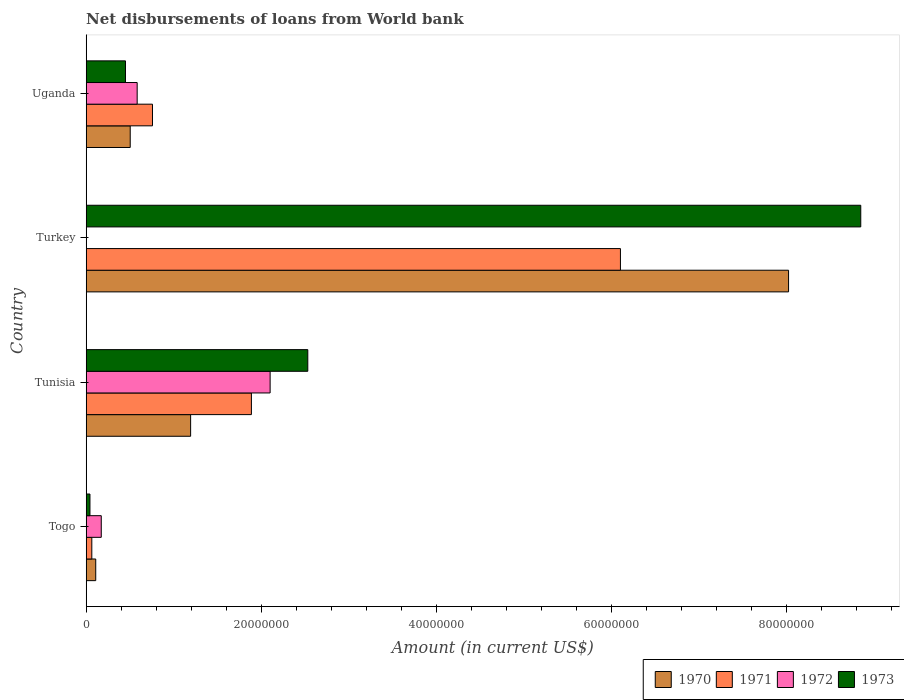How many different coloured bars are there?
Your answer should be very brief. 4. How many groups of bars are there?
Give a very brief answer. 4. Are the number of bars per tick equal to the number of legend labels?
Offer a terse response. No. How many bars are there on the 2nd tick from the bottom?
Your answer should be very brief. 4. What is the label of the 4th group of bars from the top?
Keep it short and to the point. Togo. What is the amount of loan disbursed from World Bank in 1971 in Uganda?
Offer a very short reply. 7.57e+06. Across all countries, what is the maximum amount of loan disbursed from World Bank in 1970?
Offer a very short reply. 8.02e+07. Across all countries, what is the minimum amount of loan disbursed from World Bank in 1973?
Your answer should be compact. 4.29e+05. In which country was the amount of loan disbursed from World Bank in 1973 maximum?
Your answer should be very brief. Turkey. What is the total amount of loan disbursed from World Bank in 1972 in the graph?
Your answer should be very brief. 2.86e+07. What is the difference between the amount of loan disbursed from World Bank in 1970 in Tunisia and that in Turkey?
Ensure brevity in your answer.  -6.83e+07. What is the difference between the amount of loan disbursed from World Bank in 1973 in Togo and the amount of loan disbursed from World Bank in 1970 in Uganda?
Your answer should be compact. -4.60e+06. What is the average amount of loan disbursed from World Bank in 1971 per country?
Ensure brevity in your answer.  2.20e+07. What is the difference between the amount of loan disbursed from World Bank in 1970 and amount of loan disbursed from World Bank in 1973 in Turkey?
Provide a succinct answer. -8.25e+06. In how many countries, is the amount of loan disbursed from World Bank in 1971 greater than 72000000 US$?
Make the answer very short. 0. What is the ratio of the amount of loan disbursed from World Bank in 1973 in Tunisia to that in Uganda?
Provide a succinct answer. 5.64. Is the amount of loan disbursed from World Bank in 1972 in Togo less than that in Tunisia?
Your answer should be very brief. Yes. Is the difference between the amount of loan disbursed from World Bank in 1970 in Turkey and Uganda greater than the difference between the amount of loan disbursed from World Bank in 1973 in Turkey and Uganda?
Give a very brief answer. No. What is the difference between the highest and the second highest amount of loan disbursed from World Bank in 1970?
Ensure brevity in your answer.  6.83e+07. What is the difference between the highest and the lowest amount of loan disbursed from World Bank in 1973?
Ensure brevity in your answer.  8.80e+07. How many bars are there?
Offer a very short reply. 15. Are all the bars in the graph horizontal?
Give a very brief answer. Yes. What is the difference between two consecutive major ticks on the X-axis?
Offer a very short reply. 2.00e+07. Does the graph contain grids?
Keep it short and to the point. No. What is the title of the graph?
Ensure brevity in your answer.  Net disbursements of loans from World bank. What is the label or title of the Y-axis?
Your answer should be compact. Country. What is the Amount (in current US$) of 1970 in Togo?
Provide a succinct answer. 1.09e+06. What is the Amount (in current US$) in 1971 in Togo?
Ensure brevity in your answer.  6.42e+05. What is the Amount (in current US$) of 1972 in Togo?
Your answer should be compact. 1.72e+06. What is the Amount (in current US$) of 1973 in Togo?
Give a very brief answer. 4.29e+05. What is the Amount (in current US$) in 1970 in Tunisia?
Provide a succinct answer. 1.19e+07. What is the Amount (in current US$) of 1971 in Tunisia?
Ensure brevity in your answer.  1.89e+07. What is the Amount (in current US$) in 1972 in Tunisia?
Ensure brevity in your answer.  2.10e+07. What is the Amount (in current US$) of 1973 in Tunisia?
Keep it short and to the point. 2.53e+07. What is the Amount (in current US$) of 1970 in Turkey?
Your answer should be compact. 8.02e+07. What is the Amount (in current US$) of 1971 in Turkey?
Offer a very short reply. 6.10e+07. What is the Amount (in current US$) in 1973 in Turkey?
Provide a succinct answer. 8.85e+07. What is the Amount (in current US$) in 1970 in Uganda?
Keep it short and to the point. 5.03e+06. What is the Amount (in current US$) in 1971 in Uganda?
Offer a terse response. 7.57e+06. What is the Amount (in current US$) of 1972 in Uganda?
Offer a very short reply. 5.82e+06. What is the Amount (in current US$) in 1973 in Uganda?
Provide a succinct answer. 4.49e+06. Across all countries, what is the maximum Amount (in current US$) of 1970?
Give a very brief answer. 8.02e+07. Across all countries, what is the maximum Amount (in current US$) in 1971?
Offer a very short reply. 6.10e+07. Across all countries, what is the maximum Amount (in current US$) in 1972?
Your response must be concise. 2.10e+07. Across all countries, what is the maximum Amount (in current US$) in 1973?
Your answer should be very brief. 8.85e+07. Across all countries, what is the minimum Amount (in current US$) of 1970?
Ensure brevity in your answer.  1.09e+06. Across all countries, what is the minimum Amount (in current US$) of 1971?
Your response must be concise. 6.42e+05. Across all countries, what is the minimum Amount (in current US$) of 1972?
Offer a very short reply. 0. Across all countries, what is the minimum Amount (in current US$) in 1973?
Keep it short and to the point. 4.29e+05. What is the total Amount (in current US$) in 1970 in the graph?
Offer a very short reply. 9.83e+07. What is the total Amount (in current US$) in 1971 in the graph?
Offer a very short reply. 8.81e+07. What is the total Amount (in current US$) in 1972 in the graph?
Make the answer very short. 2.86e+07. What is the total Amount (in current US$) in 1973 in the graph?
Make the answer very short. 1.19e+08. What is the difference between the Amount (in current US$) in 1970 in Togo and that in Tunisia?
Keep it short and to the point. -1.08e+07. What is the difference between the Amount (in current US$) in 1971 in Togo and that in Tunisia?
Ensure brevity in your answer.  -1.82e+07. What is the difference between the Amount (in current US$) of 1972 in Togo and that in Tunisia?
Keep it short and to the point. -1.93e+07. What is the difference between the Amount (in current US$) in 1973 in Togo and that in Tunisia?
Keep it short and to the point. -2.49e+07. What is the difference between the Amount (in current US$) in 1970 in Togo and that in Turkey?
Keep it short and to the point. -7.91e+07. What is the difference between the Amount (in current US$) of 1971 in Togo and that in Turkey?
Provide a succinct answer. -6.04e+07. What is the difference between the Amount (in current US$) of 1973 in Togo and that in Turkey?
Offer a terse response. -8.80e+07. What is the difference between the Amount (in current US$) in 1970 in Togo and that in Uganda?
Provide a short and direct response. -3.94e+06. What is the difference between the Amount (in current US$) in 1971 in Togo and that in Uganda?
Offer a very short reply. -6.93e+06. What is the difference between the Amount (in current US$) of 1972 in Togo and that in Uganda?
Give a very brief answer. -4.10e+06. What is the difference between the Amount (in current US$) in 1973 in Togo and that in Uganda?
Make the answer very short. -4.06e+06. What is the difference between the Amount (in current US$) of 1970 in Tunisia and that in Turkey?
Provide a succinct answer. -6.83e+07. What is the difference between the Amount (in current US$) of 1971 in Tunisia and that in Turkey?
Your response must be concise. -4.22e+07. What is the difference between the Amount (in current US$) of 1973 in Tunisia and that in Turkey?
Your answer should be compact. -6.32e+07. What is the difference between the Amount (in current US$) of 1970 in Tunisia and that in Uganda?
Keep it short and to the point. 6.90e+06. What is the difference between the Amount (in current US$) of 1971 in Tunisia and that in Uganda?
Provide a short and direct response. 1.13e+07. What is the difference between the Amount (in current US$) in 1972 in Tunisia and that in Uganda?
Keep it short and to the point. 1.52e+07. What is the difference between the Amount (in current US$) of 1973 in Tunisia and that in Uganda?
Ensure brevity in your answer.  2.08e+07. What is the difference between the Amount (in current US$) in 1970 in Turkey and that in Uganda?
Your answer should be compact. 7.52e+07. What is the difference between the Amount (in current US$) in 1971 in Turkey and that in Uganda?
Ensure brevity in your answer.  5.35e+07. What is the difference between the Amount (in current US$) of 1973 in Turkey and that in Uganda?
Your answer should be very brief. 8.40e+07. What is the difference between the Amount (in current US$) of 1970 in Togo and the Amount (in current US$) of 1971 in Tunisia?
Offer a very short reply. -1.78e+07. What is the difference between the Amount (in current US$) in 1970 in Togo and the Amount (in current US$) in 1972 in Tunisia?
Your answer should be compact. -1.99e+07. What is the difference between the Amount (in current US$) in 1970 in Togo and the Amount (in current US$) in 1973 in Tunisia?
Give a very brief answer. -2.42e+07. What is the difference between the Amount (in current US$) in 1971 in Togo and the Amount (in current US$) in 1972 in Tunisia?
Your answer should be compact. -2.04e+07. What is the difference between the Amount (in current US$) in 1971 in Togo and the Amount (in current US$) in 1973 in Tunisia?
Make the answer very short. -2.47e+07. What is the difference between the Amount (in current US$) in 1972 in Togo and the Amount (in current US$) in 1973 in Tunisia?
Offer a very short reply. -2.36e+07. What is the difference between the Amount (in current US$) in 1970 in Togo and the Amount (in current US$) in 1971 in Turkey?
Provide a succinct answer. -5.99e+07. What is the difference between the Amount (in current US$) in 1970 in Togo and the Amount (in current US$) in 1973 in Turkey?
Give a very brief answer. -8.74e+07. What is the difference between the Amount (in current US$) of 1971 in Togo and the Amount (in current US$) of 1973 in Turkey?
Ensure brevity in your answer.  -8.78e+07. What is the difference between the Amount (in current US$) of 1972 in Togo and the Amount (in current US$) of 1973 in Turkey?
Your answer should be very brief. -8.68e+07. What is the difference between the Amount (in current US$) in 1970 in Togo and the Amount (in current US$) in 1971 in Uganda?
Your answer should be compact. -6.48e+06. What is the difference between the Amount (in current US$) in 1970 in Togo and the Amount (in current US$) in 1972 in Uganda?
Make the answer very short. -4.73e+06. What is the difference between the Amount (in current US$) of 1970 in Togo and the Amount (in current US$) of 1973 in Uganda?
Provide a succinct answer. -3.40e+06. What is the difference between the Amount (in current US$) of 1971 in Togo and the Amount (in current US$) of 1972 in Uganda?
Your answer should be very brief. -5.18e+06. What is the difference between the Amount (in current US$) in 1971 in Togo and the Amount (in current US$) in 1973 in Uganda?
Your answer should be compact. -3.85e+06. What is the difference between the Amount (in current US$) of 1972 in Togo and the Amount (in current US$) of 1973 in Uganda?
Provide a short and direct response. -2.77e+06. What is the difference between the Amount (in current US$) of 1970 in Tunisia and the Amount (in current US$) of 1971 in Turkey?
Keep it short and to the point. -4.91e+07. What is the difference between the Amount (in current US$) of 1970 in Tunisia and the Amount (in current US$) of 1973 in Turkey?
Ensure brevity in your answer.  -7.65e+07. What is the difference between the Amount (in current US$) in 1971 in Tunisia and the Amount (in current US$) in 1973 in Turkey?
Keep it short and to the point. -6.96e+07. What is the difference between the Amount (in current US$) in 1972 in Tunisia and the Amount (in current US$) in 1973 in Turkey?
Offer a terse response. -6.75e+07. What is the difference between the Amount (in current US$) of 1970 in Tunisia and the Amount (in current US$) of 1971 in Uganda?
Your answer should be very brief. 4.36e+06. What is the difference between the Amount (in current US$) of 1970 in Tunisia and the Amount (in current US$) of 1972 in Uganda?
Keep it short and to the point. 6.11e+06. What is the difference between the Amount (in current US$) of 1970 in Tunisia and the Amount (in current US$) of 1973 in Uganda?
Keep it short and to the point. 7.44e+06. What is the difference between the Amount (in current US$) in 1971 in Tunisia and the Amount (in current US$) in 1972 in Uganda?
Keep it short and to the point. 1.30e+07. What is the difference between the Amount (in current US$) of 1971 in Tunisia and the Amount (in current US$) of 1973 in Uganda?
Your answer should be very brief. 1.44e+07. What is the difference between the Amount (in current US$) of 1972 in Tunisia and the Amount (in current US$) of 1973 in Uganda?
Provide a succinct answer. 1.65e+07. What is the difference between the Amount (in current US$) in 1970 in Turkey and the Amount (in current US$) in 1971 in Uganda?
Ensure brevity in your answer.  7.27e+07. What is the difference between the Amount (in current US$) of 1970 in Turkey and the Amount (in current US$) of 1972 in Uganda?
Make the answer very short. 7.44e+07. What is the difference between the Amount (in current US$) in 1970 in Turkey and the Amount (in current US$) in 1973 in Uganda?
Offer a very short reply. 7.57e+07. What is the difference between the Amount (in current US$) of 1971 in Turkey and the Amount (in current US$) of 1972 in Uganda?
Provide a succinct answer. 5.52e+07. What is the difference between the Amount (in current US$) in 1971 in Turkey and the Amount (in current US$) in 1973 in Uganda?
Keep it short and to the point. 5.65e+07. What is the average Amount (in current US$) of 1970 per country?
Provide a short and direct response. 2.46e+07. What is the average Amount (in current US$) in 1971 per country?
Your answer should be compact. 2.20e+07. What is the average Amount (in current US$) of 1972 per country?
Your answer should be very brief. 7.14e+06. What is the average Amount (in current US$) in 1973 per country?
Your response must be concise. 2.97e+07. What is the difference between the Amount (in current US$) in 1970 and Amount (in current US$) in 1971 in Togo?
Offer a very short reply. 4.49e+05. What is the difference between the Amount (in current US$) of 1970 and Amount (in current US$) of 1972 in Togo?
Make the answer very short. -6.31e+05. What is the difference between the Amount (in current US$) in 1970 and Amount (in current US$) in 1973 in Togo?
Offer a very short reply. 6.62e+05. What is the difference between the Amount (in current US$) of 1971 and Amount (in current US$) of 1972 in Togo?
Provide a succinct answer. -1.08e+06. What is the difference between the Amount (in current US$) in 1971 and Amount (in current US$) in 1973 in Togo?
Offer a terse response. 2.13e+05. What is the difference between the Amount (in current US$) in 1972 and Amount (in current US$) in 1973 in Togo?
Give a very brief answer. 1.29e+06. What is the difference between the Amount (in current US$) in 1970 and Amount (in current US$) in 1971 in Tunisia?
Ensure brevity in your answer.  -6.94e+06. What is the difference between the Amount (in current US$) of 1970 and Amount (in current US$) of 1972 in Tunisia?
Keep it short and to the point. -9.08e+06. What is the difference between the Amount (in current US$) of 1970 and Amount (in current US$) of 1973 in Tunisia?
Offer a terse response. -1.34e+07. What is the difference between the Amount (in current US$) of 1971 and Amount (in current US$) of 1972 in Tunisia?
Offer a very short reply. -2.14e+06. What is the difference between the Amount (in current US$) of 1971 and Amount (in current US$) of 1973 in Tunisia?
Provide a short and direct response. -6.44e+06. What is the difference between the Amount (in current US$) of 1972 and Amount (in current US$) of 1973 in Tunisia?
Give a very brief answer. -4.30e+06. What is the difference between the Amount (in current US$) in 1970 and Amount (in current US$) in 1971 in Turkey?
Your answer should be compact. 1.92e+07. What is the difference between the Amount (in current US$) of 1970 and Amount (in current US$) of 1973 in Turkey?
Make the answer very short. -8.25e+06. What is the difference between the Amount (in current US$) in 1971 and Amount (in current US$) in 1973 in Turkey?
Make the answer very short. -2.75e+07. What is the difference between the Amount (in current US$) of 1970 and Amount (in current US$) of 1971 in Uganda?
Offer a very short reply. -2.54e+06. What is the difference between the Amount (in current US$) of 1970 and Amount (in current US$) of 1972 in Uganda?
Your answer should be compact. -7.94e+05. What is the difference between the Amount (in current US$) in 1970 and Amount (in current US$) in 1973 in Uganda?
Your response must be concise. 5.40e+05. What is the difference between the Amount (in current US$) in 1971 and Amount (in current US$) in 1972 in Uganda?
Ensure brevity in your answer.  1.75e+06. What is the difference between the Amount (in current US$) of 1971 and Amount (in current US$) of 1973 in Uganda?
Make the answer very short. 3.08e+06. What is the difference between the Amount (in current US$) of 1972 and Amount (in current US$) of 1973 in Uganda?
Offer a very short reply. 1.33e+06. What is the ratio of the Amount (in current US$) in 1970 in Togo to that in Tunisia?
Ensure brevity in your answer.  0.09. What is the ratio of the Amount (in current US$) in 1971 in Togo to that in Tunisia?
Ensure brevity in your answer.  0.03. What is the ratio of the Amount (in current US$) in 1972 in Togo to that in Tunisia?
Make the answer very short. 0.08. What is the ratio of the Amount (in current US$) of 1973 in Togo to that in Tunisia?
Make the answer very short. 0.02. What is the ratio of the Amount (in current US$) in 1970 in Togo to that in Turkey?
Offer a very short reply. 0.01. What is the ratio of the Amount (in current US$) in 1971 in Togo to that in Turkey?
Make the answer very short. 0.01. What is the ratio of the Amount (in current US$) in 1973 in Togo to that in Turkey?
Provide a succinct answer. 0. What is the ratio of the Amount (in current US$) in 1970 in Togo to that in Uganda?
Ensure brevity in your answer.  0.22. What is the ratio of the Amount (in current US$) in 1971 in Togo to that in Uganda?
Your response must be concise. 0.08. What is the ratio of the Amount (in current US$) in 1972 in Togo to that in Uganda?
Your answer should be very brief. 0.3. What is the ratio of the Amount (in current US$) of 1973 in Togo to that in Uganda?
Offer a terse response. 0.1. What is the ratio of the Amount (in current US$) of 1970 in Tunisia to that in Turkey?
Make the answer very short. 0.15. What is the ratio of the Amount (in current US$) in 1971 in Tunisia to that in Turkey?
Your answer should be compact. 0.31. What is the ratio of the Amount (in current US$) in 1973 in Tunisia to that in Turkey?
Offer a very short reply. 0.29. What is the ratio of the Amount (in current US$) of 1970 in Tunisia to that in Uganda?
Offer a very short reply. 2.37. What is the ratio of the Amount (in current US$) in 1971 in Tunisia to that in Uganda?
Give a very brief answer. 2.49. What is the ratio of the Amount (in current US$) of 1972 in Tunisia to that in Uganda?
Give a very brief answer. 3.61. What is the ratio of the Amount (in current US$) of 1973 in Tunisia to that in Uganda?
Your response must be concise. 5.64. What is the ratio of the Amount (in current US$) in 1970 in Turkey to that in Uganda?
Your response must be concise. 15.95. What is the ratio of the Amount (in current US$) of 1971 in Turkey to that in Uganda?
Make the answer very short. 8.06. What is the ratio of the Amount (in current US$) in 1973 in Turkey to that in Uganda?
Offer a terse response. 19.71. What is the difference between the highest and the second highest Amount (in current US$) of 1970?
Provide a short and direct response. 6.83e+07. What is the difference between the highest and the second highest Amount (in current US$) of 1971?
Your answer should be very brief. 4.22e+07. What is the difference between the highest and the second highest Amount (in current US$) in 1972?
Offer a very short reply. 1.52e+07. What is the difference between the highest and the second highest Amount (in current US$) in 1973?
Provide a succinct answer. 6.32e+07. What is the difference between the highest and the lowest Amount (in current US$) in 1970?
Offer a very short reply. 7.91e+07. What is the difference between the highest and the lowest Amount (in current US$) of 1971?
Provide a succinct answer. 6.04e+07. What is the difference between the highest and the lowest Amount (in current US$) of 1972?
Make the answer very short. 2.10e+07. What is the difference between the highest and the lowest Amount (in current US$) of 1973?
Give a very brief answer. 8.80e+07. 